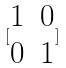Convert formula to latex. <formula><loc_0><loc_0><loc_500><loc_500>[ \begin{matrix} 1 & 0 \\ 0 & 1 \end{matrix} ]</formula> 